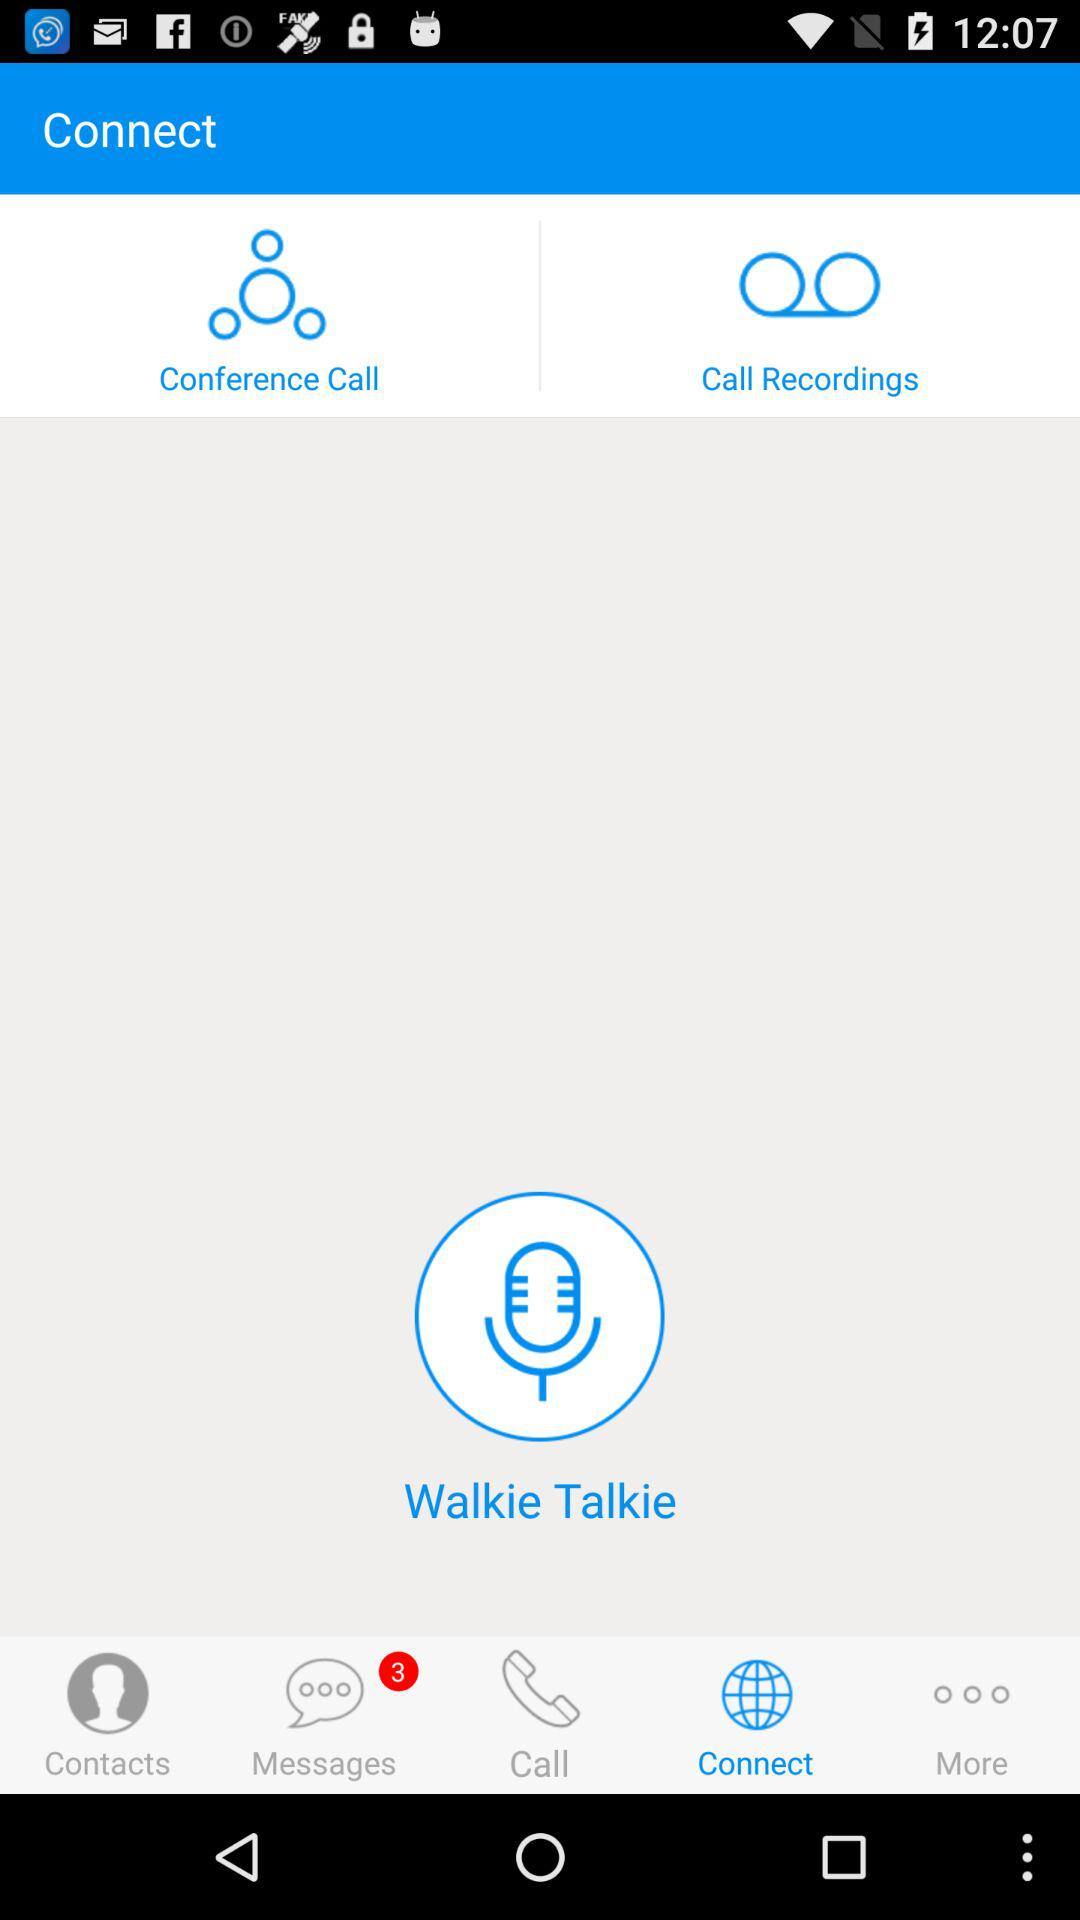Which option is selected? The selected option is "Connect". 